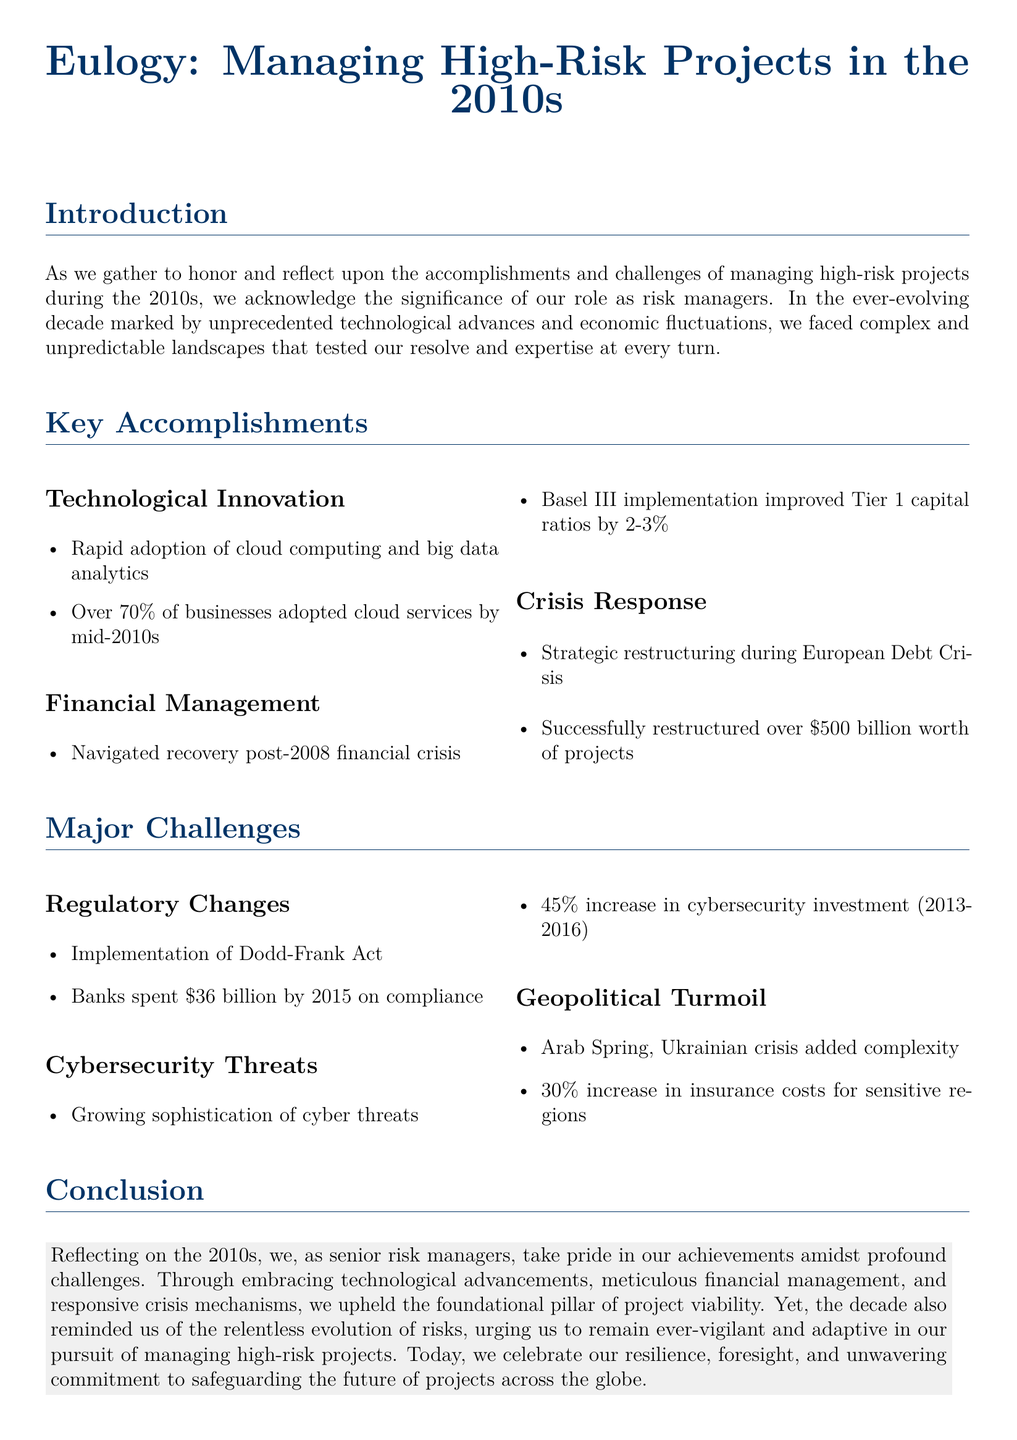What percentage of businesses adopted cloud services by the mid-2010s? The document states that over 70 percent of businesses adopted cloud services by the mid-2010s.
Answer: Over 70% What was the improvement in Tier 1 capital ratios due to Basel III implementation? The document mentions that Basel III implementation improved Tier 1 capital ratios by 2-3 percent.
Answer: 2-3% How much did banks spend on compliance by 2015 due to the Dodd-Frank Act? According to the document, banks spent 36 billion dollars by 2015 on compliance.
Answer: 36 billion What was the worth of projects successfully restructured during the European Debt Crisis? The document indicates that more than 500 billion dollars worth of projects were successfully restructured.
Answer: 500 billion What was the percentage increase in cybersecurity investment from 2013 to 2016? The document states that there was a 45 percent increase in cybersecurity investment during that period.
Answer: 45 percent What geopolitical events added complexity to project management in the 2010s? The document lists the Arab Spring and the Ukrainian crisis as significant geopolitical events adding complexity.
Answer: Arab Spring, Ukrainian crisis What does the document highlight as a critical element for managing high-risk projects? The conclusion of the document emphasizes the foundational pillar of project viability as critical in managing high-risk projects.
Answer: Project viability What significant technological advancement is mentioned in the accomplishments? The document refers to the rapid adoption of cloud computing as a significant technological advancement.
Answer: Cloud computing 